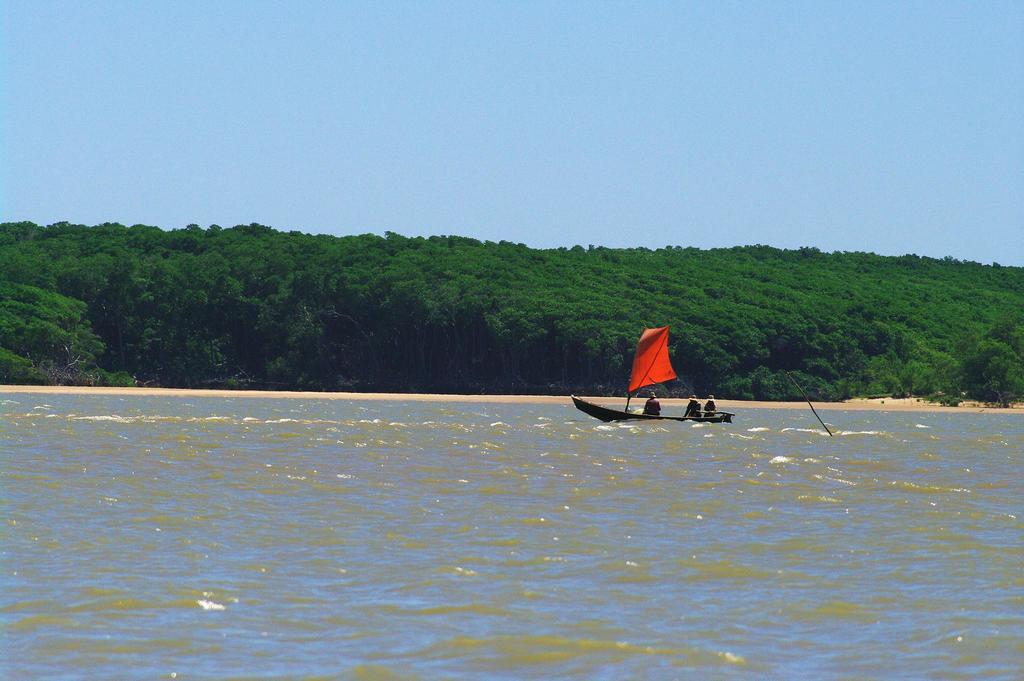What is in the foreground of the image? There is water in the foreground of the image. What is located in the water? There is a ship in the water. How many people are on the ship? There are three persons in the ship. What can be seen in the background of the image? There are trees in the background of the image. What is the color of the sky in the image? The sky is blue in the image. How many trucks are parked near the ship in the image? There are no trucks present in the image; it features a ship with three persons on it. Are there any horses visible in the image? There are no horses present in the image. 